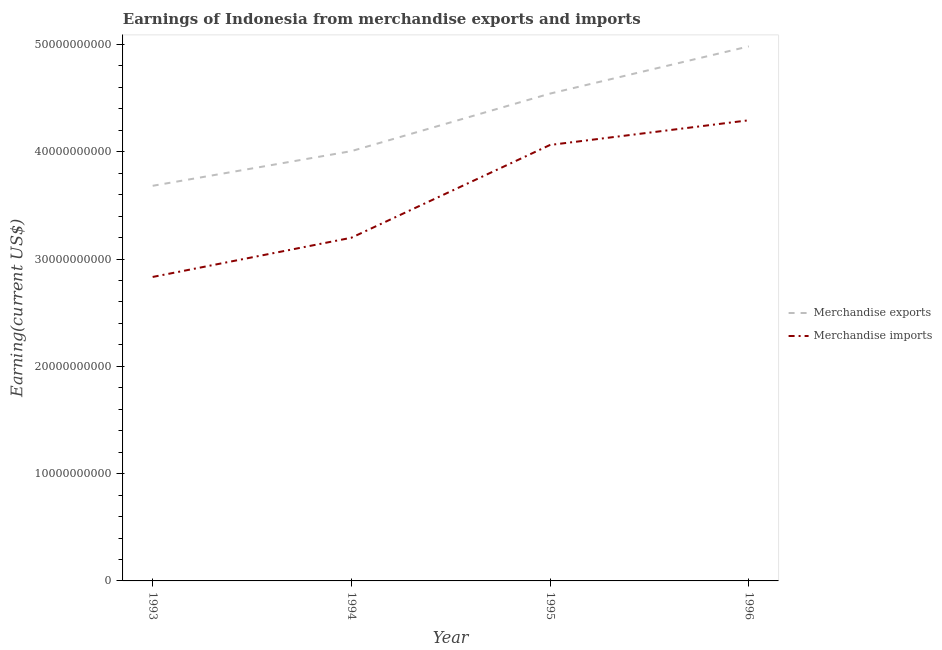Is the number of lines equal to the number of legend labels?
Keep it short and to the point. Yes. What is the earnings from merchandise imports in 1993?
Keep it short and to the point. 2.83e+1. Across all years, what is the maximum earnings from merchandise imports?
Offer a very short reply. 4.29e+1. Across all years, what is the minimum earnings from merchandise exports?
Provide a succinct answer. 3.68e+1. In which year was the earnings from merchandise imports maximum?
Your response must be concise. 1996. What is the total earnings from merchandise imports in the graph?
Your response must be concise. 1.44e+11. What is the difference between the earnings from merchandise imports in 1993 and that in 1995?
Provide a short and direct response. -1.23e+1. What is the difference between the earnings from merchandise exports in 1993 and the earnings from merchandise imports in 1996?
Your answer should be compact. -6.11e+09. What is the average earnings from merchandise exports per year?
Your answer should be compact. 4.30e+1. In the year 1994, what is the difference between the earnings from merchandise imports and earnings from merchandise exports?
Your answer should be compact. -8.07e+09. What is the ratio of the earnings from merchandise exports in 1994 to that in 1996?
Ensure brevity in your answer.  0.8. What is the difference between the highest and the second highest earnings from merchandise exports?
Make the answer very short. 4.40e+09. What is the difference between the highest and the lowest earnings from merchandise imports?
Make the answer very short. 1.46e+1. Does the earnings from merchandise imports monotonically increase over the years?
Make the answer very short. Yes. How many lines are there?
Make the answer very short. 2. How many years are there in the graph?
Provide a short and direct response. 4. Are the values on the major ticks of Y-axis written in scientific E-notation?
Your answer should be compact. No. Where does the legend appear in the graph?
Keep it short and to the point. Center right. How many legend labels are there?
Give a very brief answer. 2. How are the legend labels stacked?
Offer a very short reply. Vertical. What is the title of the graph?
Make the answer very short. Earnings of Indonesia from merchandise exports and imports. Does "Commercial service exports" appear as one of the legend labels in the graph?
Your answer should be very brief. No. What is the label or title of the X-axis?
Provide a succinct answer. Year. What is the label or title of the Y-axis?
Provide a succinct answer. Earning(current US$). What is the Earning(current US$) of Merchandise exports in 1993?
Make the answer very short. 3.68e+1. What is the Earning(current US$) in Merchandise imports in 1993?
Make the answer very short. 2.83e+1. What is the Earning(current US$) in Merchandise exports in 1994?
Provide a short and direct response. 4.01e+1. What is the Earning(current US$) in Merchandise imports in 1994?
Keep it short and to the point. 3.20e+1. What is the Earning(current US$) in Merchandise exports in 1995?
Your response must be concise. 4.54e+1. What is the Earning(current US$) in Merchandise imports in 1995?
Make the answer very short. 4.06e+1. What is the Earning(current US$) of Merchandise exports in 1996?
Your answer should be very brief. 4.98e+1. What is the Earning(current US$) in Merchandise imports in 1996?
Offer a very short reply. 4.29e+1. Across all years, what is the maximum Earning(current US$) in Merchandise exports?
Keep it short and to the point. 4.98e+1. Across all years, what is the maximum Earning(current US$) in Merchandise imports?
Provide a short and direct response. 4.29e+1. Across all years, what is the minimum Earning(current US$) in Merchandise exports?
Your answer should be very brief. 3.68e+1. Across all years, what is the minimum Earning(current US$) in Merchandise imports?
Ensure brevity in your answer.  2.83e+1. What is the total Earning(current US$) in Merchandise exports in the graph?
Offer a terse response. 1.72e+11. What is the total Earning(current US$) of Merchandise imports in the graph?
Provide a short and direct response. 1.44e+11. What is the difference between the Earning(current US$) of Merchandise exports in 1993 and that in 1994?
Ensure brevity in your answer.  -3.23e+09. What is the difference between the Earning(current US$) in Merchandise imports in 1993 and that in 1994?
Provide a succinct answer. -3.66e+09. What is the difference between the Earning(current US$) of Merchandise exports in 1993 and that in 1995?
Keep it short and to the point. -8.59e+09. What is the difference between the Earning(current US$) in Merchandise imports in 1993 and that in 1995?
Provide a short and direct response. -1.23e+1. What is the difference between the Earning(current US$) in Merchandise exports in 1993 and that in 1996?
Offer a terse response. -1.30e+1. What is the difference between the Earning(current US$) of Merchandise imports in 1993 and that in 1996?
Your answer should be very brief. -1.46e+1. What is the difference between the Earning(current US$) of Merchandise exports in 1994 and that in 1995?
Your answer should be very brief. -5.36e+09. What is the difference between the Earning(current US$) of Merchandise imports in 1994 and that in 1995?
Ensure brevity in your answer.  -8.65e+09. What is the difference between the Earning(current US$) in Merchandise exports in 1994 and that in 1996?
Give a very brief answer. -9.76e+09. What is the difference between the Earning(current US$) in Merchandise imports in 1994 and that in 1996?
Make the answer very short. -1.09e+1. What is the difference between the Earning(current US$) in Merchandise exports in 1995 and that in 1996?
Give a very brief answer. -4.40e+09. What is the difference between the Earning(current US$) in Merchandise imports in 1995 and that in 1996?
Provide a short and direct response. -2.30e+09. What is the difference between the Earning(current US$) of Merchandise exports in 1993 and the Earning(current US$) of Merchandise imports in 1994?
Give a very brief answer. 4.84e+09. What is the difference between the Earning(current US$) in Merchandise exports in 1993 and the Earning(current US$) in Merchandise imports in 1995?
Your answer should be compact. -3.81e+09. What is the difference between the Earning(current US$) in Merchandise exports in 1993 and the Earning(current US$) in Merchandise imports in 1996?
Offer a terse response. -6.11e+09. What is the difference between the Earning(current US$) of Merchandise exports in 1994 and the Earning(current US$) of Merchandise imports in 1995?
Your answer should be very brief. -5.75e+08. What is the difference between the Earning(current US$) in Merchandise exports in 1994 and the Earning(current US$) in Merchandise imports in 1996?
Offer a very short reply. -2.87e+09. What is the difference between the Earning(current US$) of Merchandise exports in 1995 and the Earning(current US$) of Merchandise imports in 1996?
Your answer should be very brief. 2.49e+09. What is the average Earning(current US$) in Merchandise exports per year?
Ensure brevity in your answer.  4.30e+1. What is the average Earning(current US$) in Merchandise imports per year?
Ensure brevity in your answer.  3.60e+1. In the year 1993, what is the difference between the Earning(current US$) in Merchandise exports and Earning(current US$) in Merchandise imports?
Your response must be concise. 8.50e+09. In the year 1994, what is the difference between the Earning(current US$) of Merchandise exports and Earning(current US$) of Merchandise imports?
Your answer should be compact. 8.07e+09. In the year 1995, what is the difference between the Earning(current US$) of Merchandise exports and Earning(current US$) of Merchandise imports?
Your response must be concise. 4.79e+09. In the year 1996, what is the difference between the Earning(current US$) in Merchandise exports and Earning(current US$) in Merchandise imports?
Make the answer very short. 6.88e+09. What is the ratio of the Earning(current US$) in Merchandise exports in 1993 to that in 1994?
Your answer should be compact. 0.92. What is the ratio of the Earning(current US$) in Merchandise imports in 1993 to that in 1994?
Offer a very short reply. 0.89. What is the ratio of the Earning(current US$) in Merchandise exports in 1993 to that in 1995?
Ensure brevity in your answer.  0.81. What is the ratio of the Earning(current US$) of Merchandise imports in 1993 to that in 1995?
Give a very brief answer. 0.7. What is the ratio of the Earning(current US$) of Merchandise exports in 1993 to that in 1996?
Offer a very short reply. 0.74. What is the ratio of the Earning(current US$) in Merchandise imports in 1993 to that in 1996?
Make the answer very short. 0.66. What is the ratio of the Earning(current US$) of Merchandise exports in 1994 to that in 1995?
Your answer should be very brief. 0.88. What is the ratio of the Earning(current US$) of Merchandise imports in 1994 to that in 1995?
Ensure brevity in your answer.  0.79. What is the ratio of the Earning(current US$) of Merchandise exports in 1994 to that in 1996?
Your response must be concise. 0.8. What is the ratio of the Earning(current US$) in Merchandise imports in 1994 to that in 1996?
Offer a very short reply. 0.74. What is the ratio of the Earning(current US$) of Merchandise exports in 1995 to that in 1996?
Your response must be concise. 0.91. What is the ratio of the Earning(current US$) of Merchandise imports in 1995 to that in 1996?
Your response must be concise. 0.95. What is the difference between the highest and the second highest Earning(current US$) of Merchandise exports?
Your answer should be very brief. 4.40e+09. What is the difference between the highest and the second highest Earning(current US$) of Merchandise imports?
Provide a succinct answer. 2.30e+09. What is the difference between the highest and the lowest Earning(current US$) in Merchandise exports?
Your answer should be very brief. 1.30e+1. What is the difference between the highest and the lowest Earning(current US$) in Merchandise imports?
Your response must be concise. 1.46e+1. 